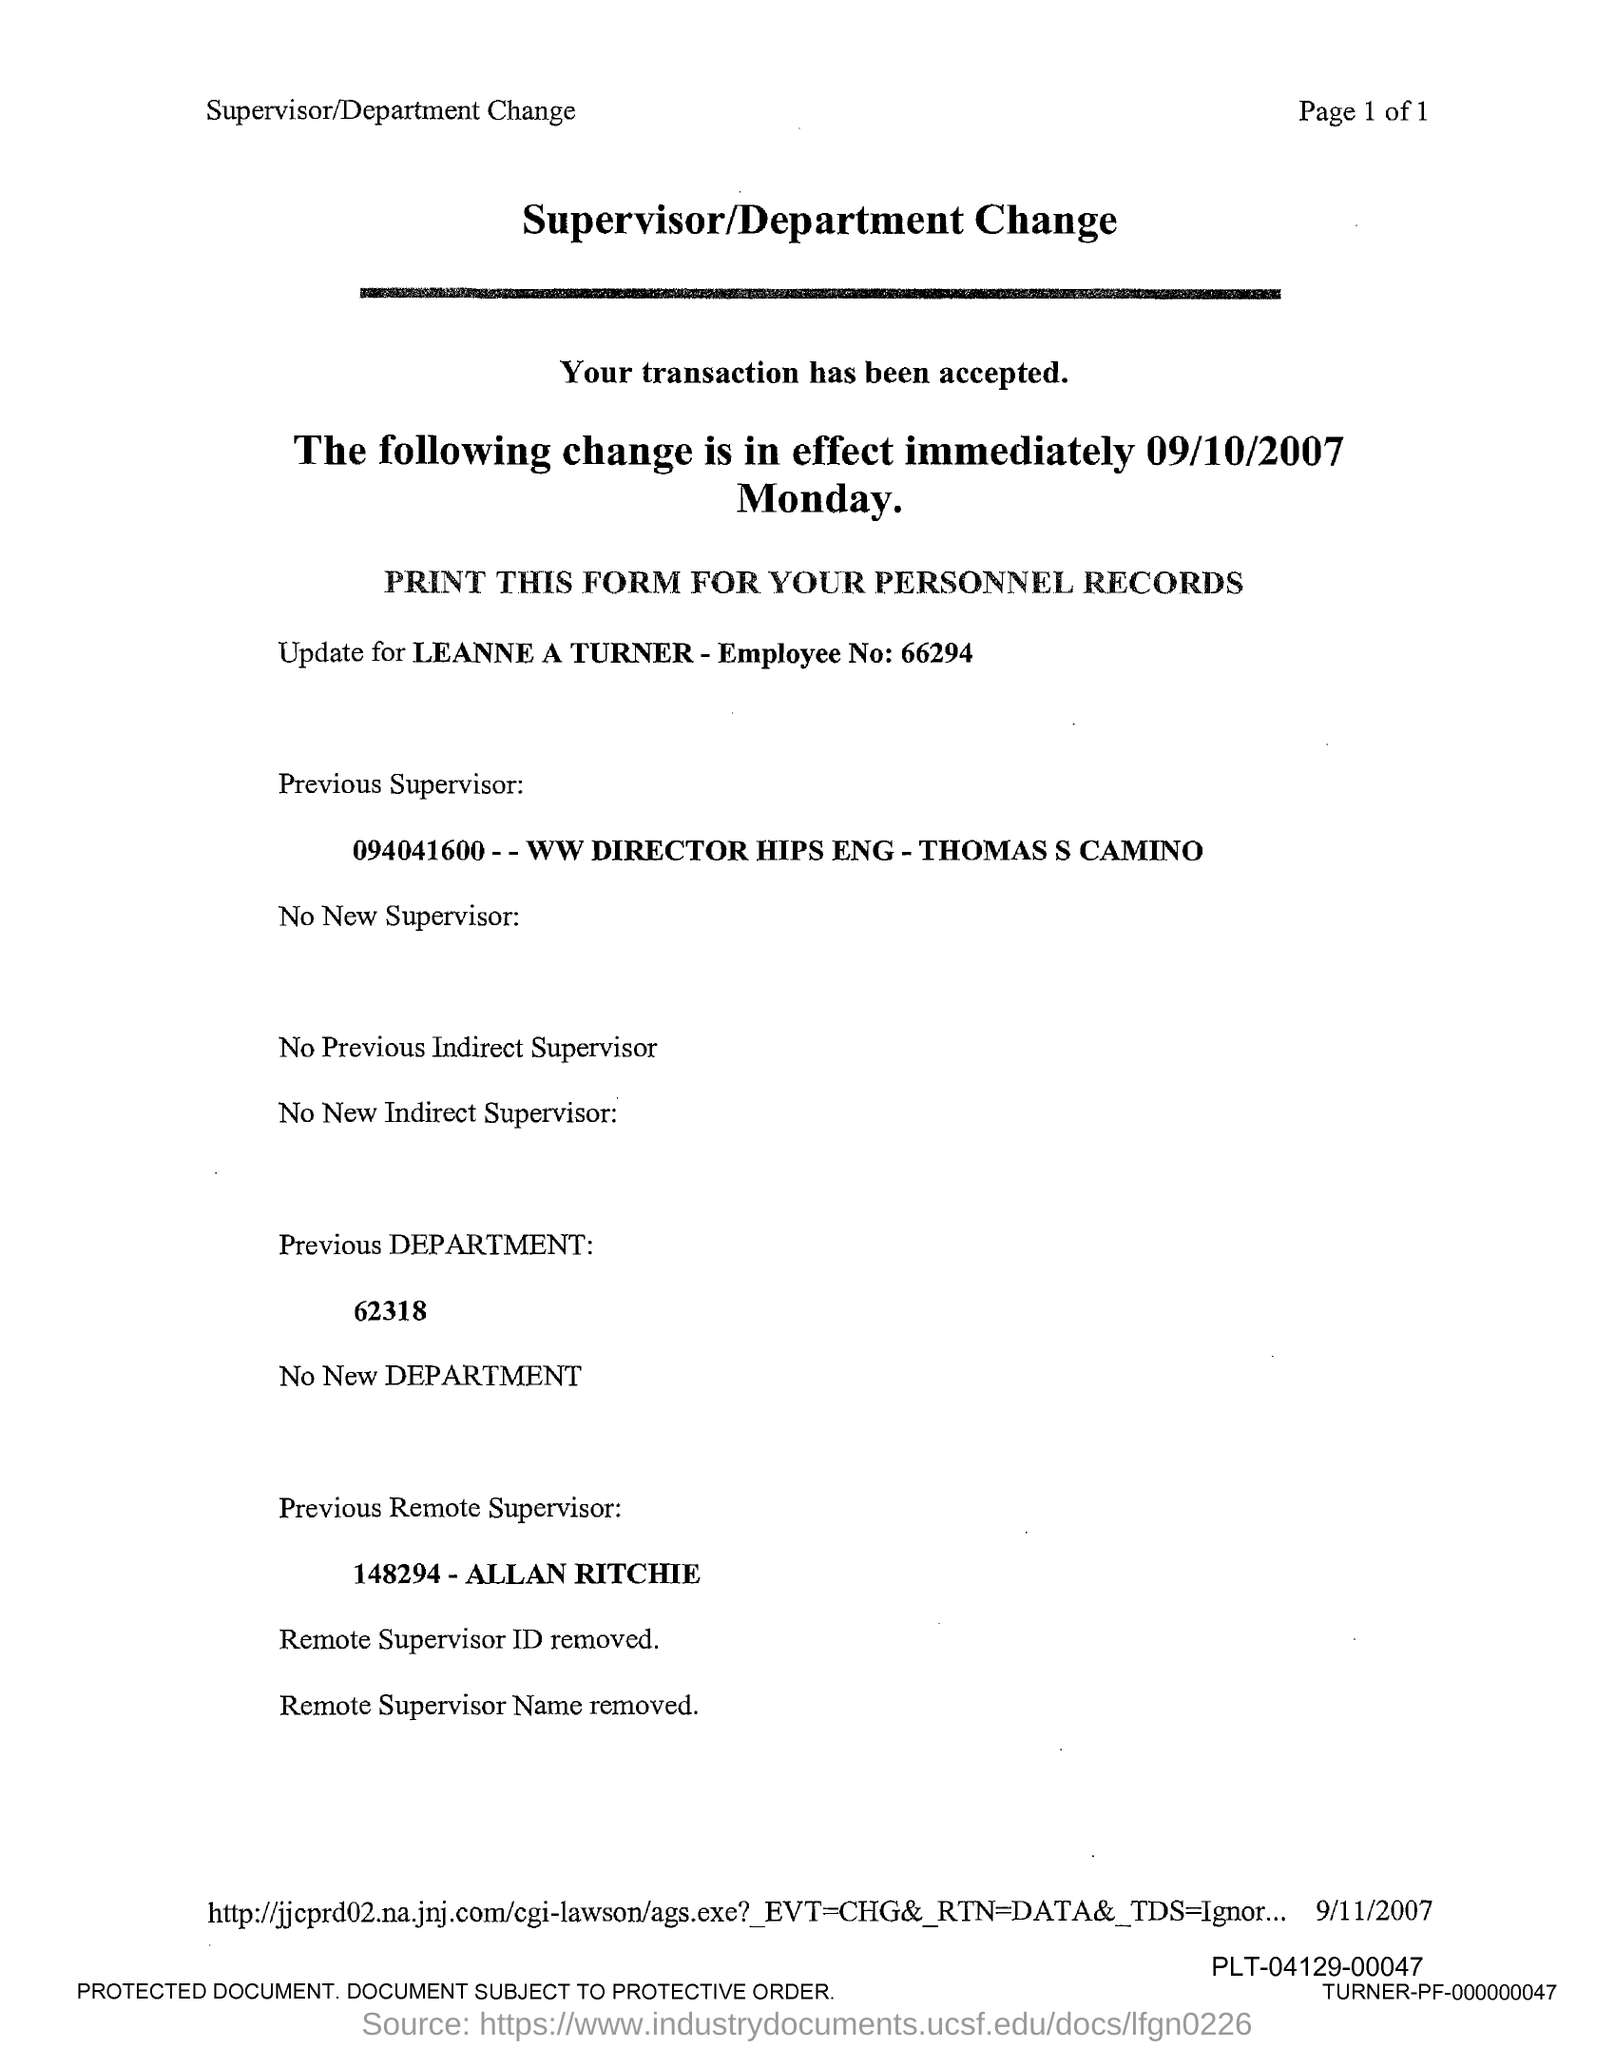Identify some key points in this picture. The title of the message is "Supervisor/Department Change Request. The previous supervisor is Thomas S Camino. Leanne Turner's employee number is 66294. The previous remote supervisor is Allan Ritchie. 